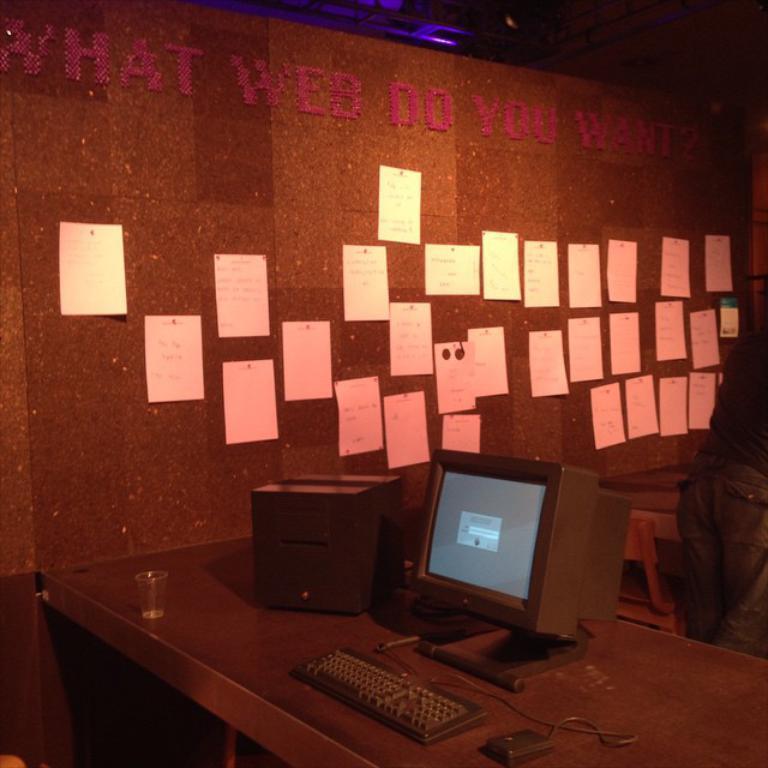Can you describe this image briefly? In this image I can see a desk and on the desk I can see a keyboard, a mouse, a monitor, a glass and a black colored object. In the background I can see the wall, few papers attached to the wall, a chair and a person standing. 